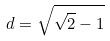Convert formula to latex. <formula><loc_0><loc_0><loc_500><loc_500>d = \sqrt { \sqrt { 2 } - 1 }</formula> 